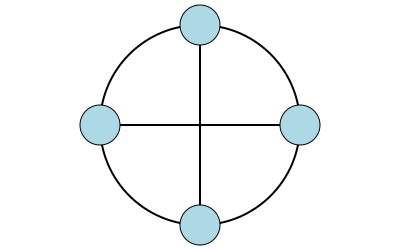Identify the network topology depicted in the diagram above. Consider the potential advantages and disadvantages of this topology in terms of fault tolerance and network performance. How might this topology be implemented in a real-world scenario, and what precautions should be taken to ensure its reliability? To identify and analyze the network topology, let's follow these steps:

1. Observe the diagram:
   - Four nodes are arranged in a circular pattern
   - Nodes are connected by lines forming a cross shape

2. Identify the topology:
   This is a Ring topology with cross-connections, also known as a Dual Ring topology.

3. Advantages:
   a) Fault tolerance: If one connection fails, data can still reach all nodes through the alternative path.
   b) Load balancing: Traffic can be distributed across both rings, potentially improving performance.
   c) Redundancy: Dual paths provide backup in case of failure.

4. Disadvantages:
   a) Complexity: More complex to set up and manage than a simple ring.
   b) Cost: Requires more cabling and hardware for cross-connections.
   c) Potential for collisions: If not managed properly, data could collide at intersections.

5. Real-world implementation:
   - Often used in high-reliability networks like financial institutions or industrial control systems.
   - Implemented using fiber optic cables for high-speed data transmission.
   - Specialized network switches or routers are used at each node to manage traffic flow.

6. Precautions for reliability:
   a) Implement robust network management protocols (e.g., Spanning Tree Protocol) to prevent loops.
   b) Use high-quality, redundant hardware at each node.
   c) Regularly test failover scenarios to ensure proper operation during failures.
   d) Implement network monitoring to quickly identify and respond to issues.
   e) Use appropriate shielding and physical protection for cables to prevent damage.

As a cautious programmer, it's crucial to thoroughly test the network configuration in a simulated environment before deploying it in production. Also, always have a rollback plan in case unexpected issues arise during implementation.
Answer: Dual Ring topology 